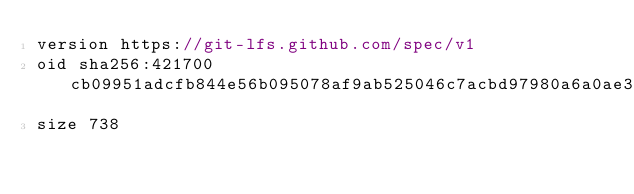Convert code to text. <code><loc_0><loc_0><loc_500><loc_500><_C++_>version https://git-lfs.github.com/spec/v1
oid sha256:421700cb09951adcfb844e56b095078af9ab525046c7acbd97980a6a0ae32feb
size 738
</code> 